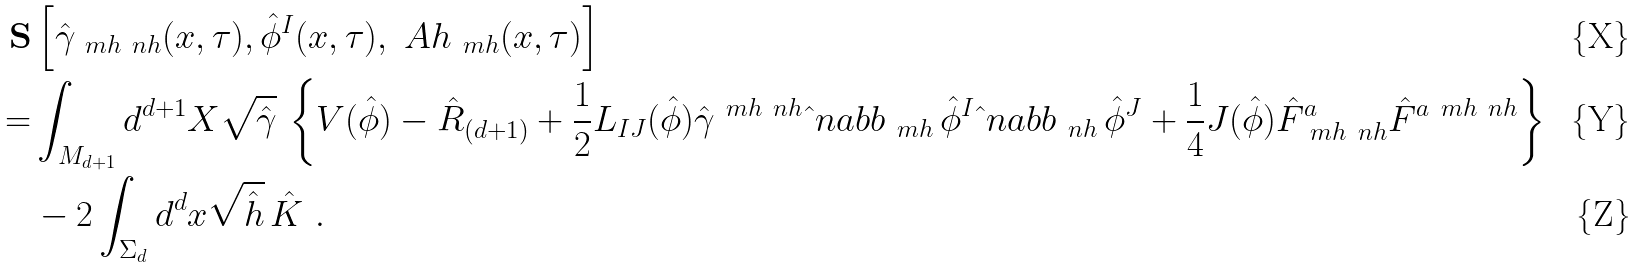<formula> <loc_0><loc_0><loc_500><loc_500>\mathbf S & \left [ \hat { \gamma } _ { \ m h \ n h } ( x , \tau ) , \hat { \phi } ^ { I } ( x , \tau ) , \ A h _ { \ m h } ( x , \tau ) \right ] \\ = & \int _ { M _ { d + 1 } } d ^ { d + 1 } X \sqrt { \hat { \gamma } } \, \left \{ V ( \hat { \phi } ) - \hat { R } _ { ( d + 1 ) } + \frac { 1 } { 2 } L _ { I J } ( \hat { \phi } ) \hat { \gamma } ^ { \ m h \ n h } \hat { \ } n a b b _ { \ m h } \, \hat { \phi } ^ { I } \hat { \ } n a b b _ { \ n h } \, \hat { \phi } ^ { J } + \frac { 1 } { 4 } J ( \hat { \phi } ) \hat { F } ^ { a } _ { \ m h \ n h } \hat { F } ^ { a \ m h \ n h } \right \} \\ & - 2 \int _ { \Sigma _ { d } } d ^ { d } x \sqrt { \hat { h } } \, \hat { K } \ .</formula> 